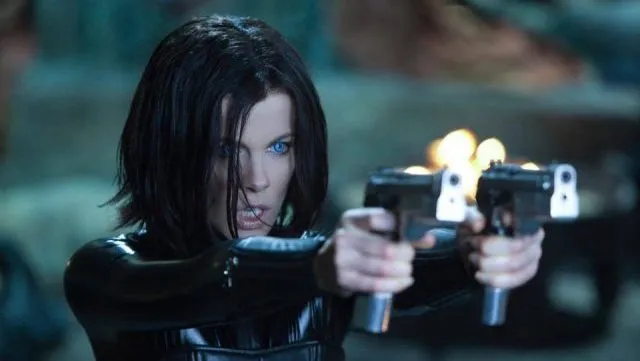Can you describe the main features of this image for me? The image portrays actress Kate Beckinsale in her iconic role as Selene from the movie 'Underworld.' Selene is depicted in a commanding stance, dressed in a sleek black leather outfit that reflects her fierce and formidable nature. She wields two pistols, both aimed towards the right, ready for action. Her hair is cut into a short, edgy bob, complementing her intense and focused expression. The setting is dark and ominous, with a blurry background bathed in blue hues that amplify the mysterious and intense atmosphere characteristic of the Underworld universe. 